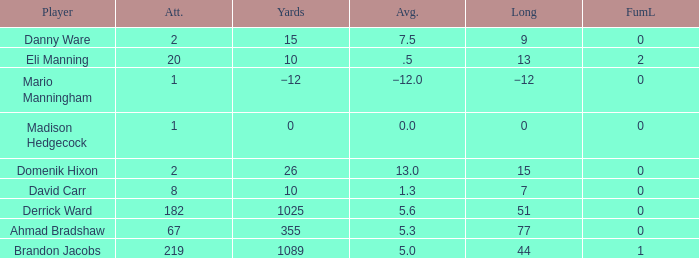Could you parse the entire table? {'header': ['Player', 'Att.', 'Yards', 'Avg.', 'Long', 'FumL'], 'rows': [['Danny Ware', '2', '15', '7.5', '9', '0'], ['Eli Manning', '20', '10', '.5', '13', '2'], ['Mario Manningham', '1', '−12', '−12.0', '−12', '0'], ['Madison Hedgecock', '1', '0', '0.0', '0', '0'], ['Domenik Hixon', '2', '26', '13.0', '15', '0'], ['David Carr', '8', '10', '1.3', '7', '0'], ['Derrick Ward', '182', '1025', '5.6', '51', '0'], ['Ahmad Bradshaw', '67', '355', '5.3', '77', '0'], ['Brandon Jacobs', '219', '1089', '5.0', '44', '1']]} What is domenik hixon's mean rush? 13.0. 